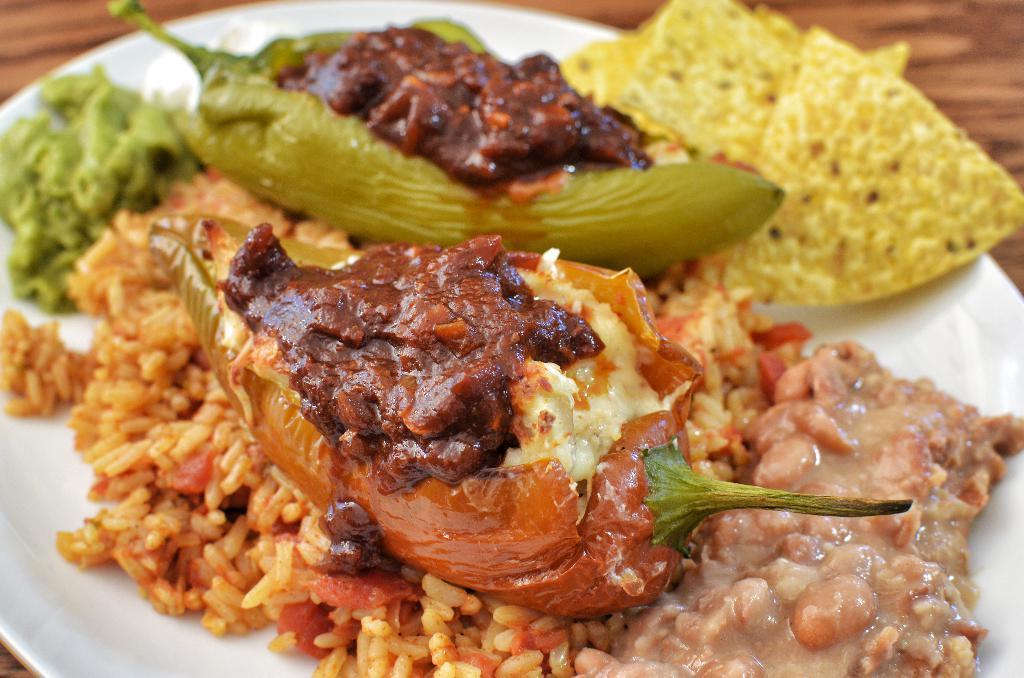How would you summarize this image in a sentence or two? In this image we can see food items on the plate, we can see the wooden surface. 